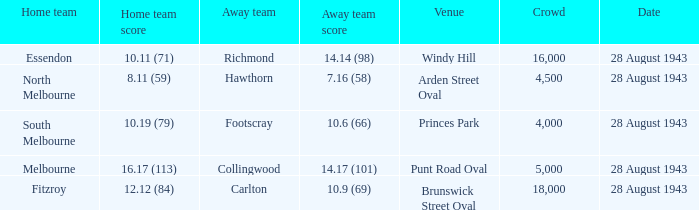What game had an 8.11 (59) score for the home team? 28 August 1943. 